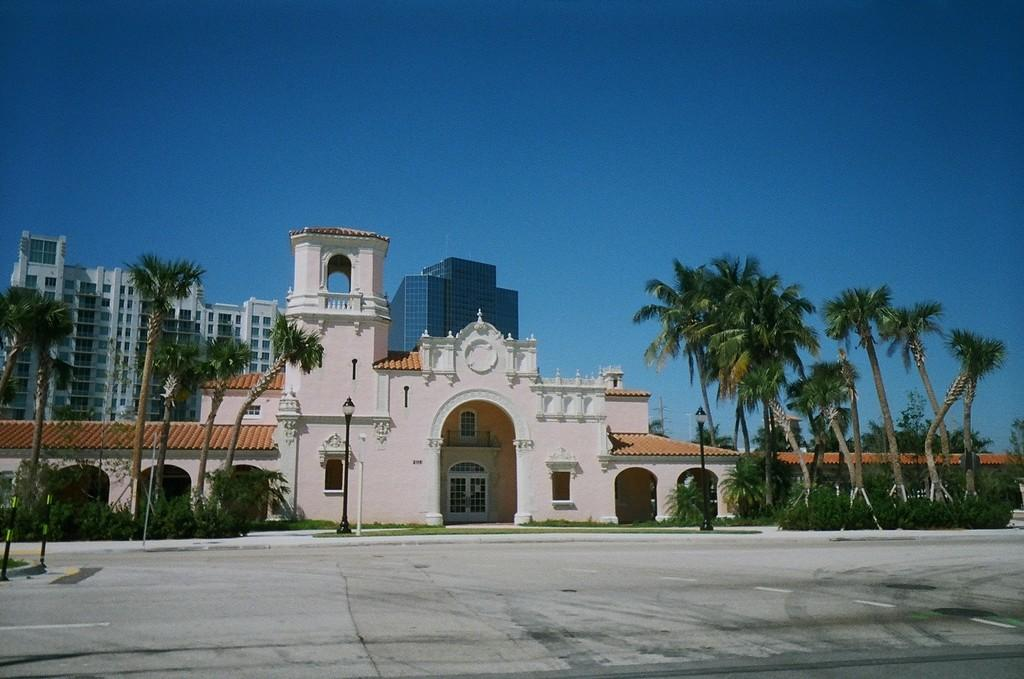What type of structures can be seen in the image? There are buildings in the image. What type of vegetation is present in the image? There are plants, trees, and grass in the image. What type of lighting is present in the image? There are street lamps in the image. What part of the natural environment is visible in the image? The sky is visible in the image. Who is the owner of the ear in the image? There is no ear present in the image. How comfortable is the grass in the image? The comfort level of the grass cannot be determined from the image alone. 